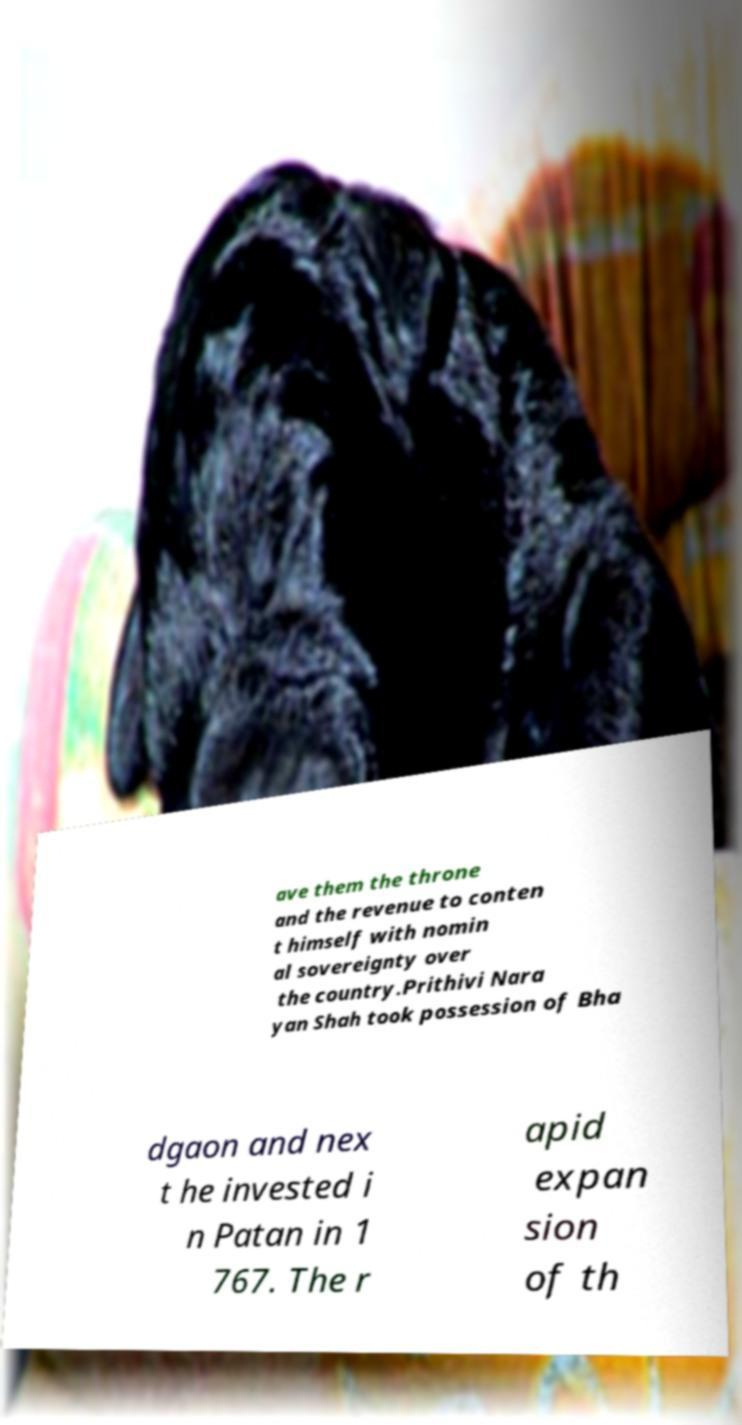Could you extract and type out the text from this image? ave them the throne and the revenue to conten t himself with nomin al sovereignty over the country.Prithivi Nara yan Shah took possession of Bha dgaon and nex t he invested i n Patan in 1 767. The r apid expan sion of th 